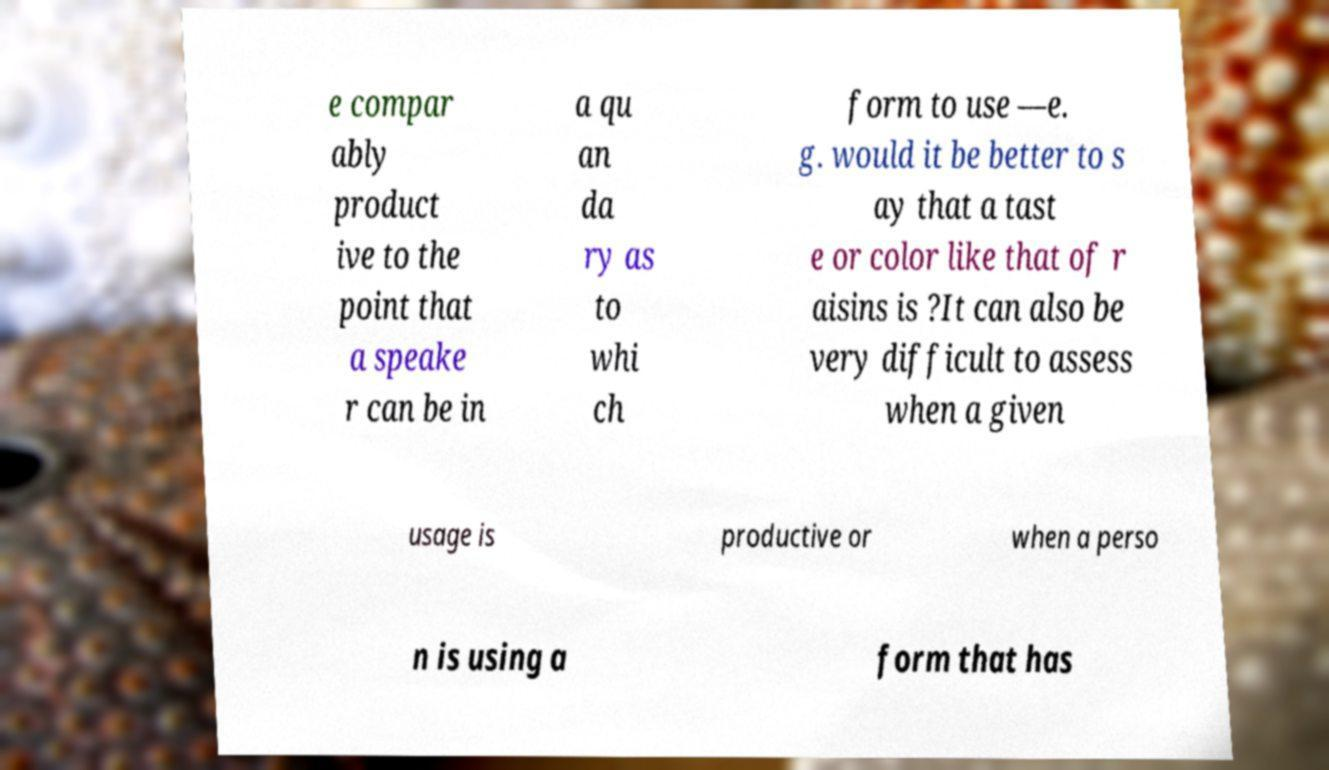What messages or text are displayed in this image? I need them in a readable, typed format. e compar ably product ive to the point that a speake r can be in a qu an da ry as to whi ch form to use —e. g. would it be better to s ay that a tast e or color like that of r aisins is ?It can also be very difficult to assess when a given usage is productive or when a perso n is using a form that has 